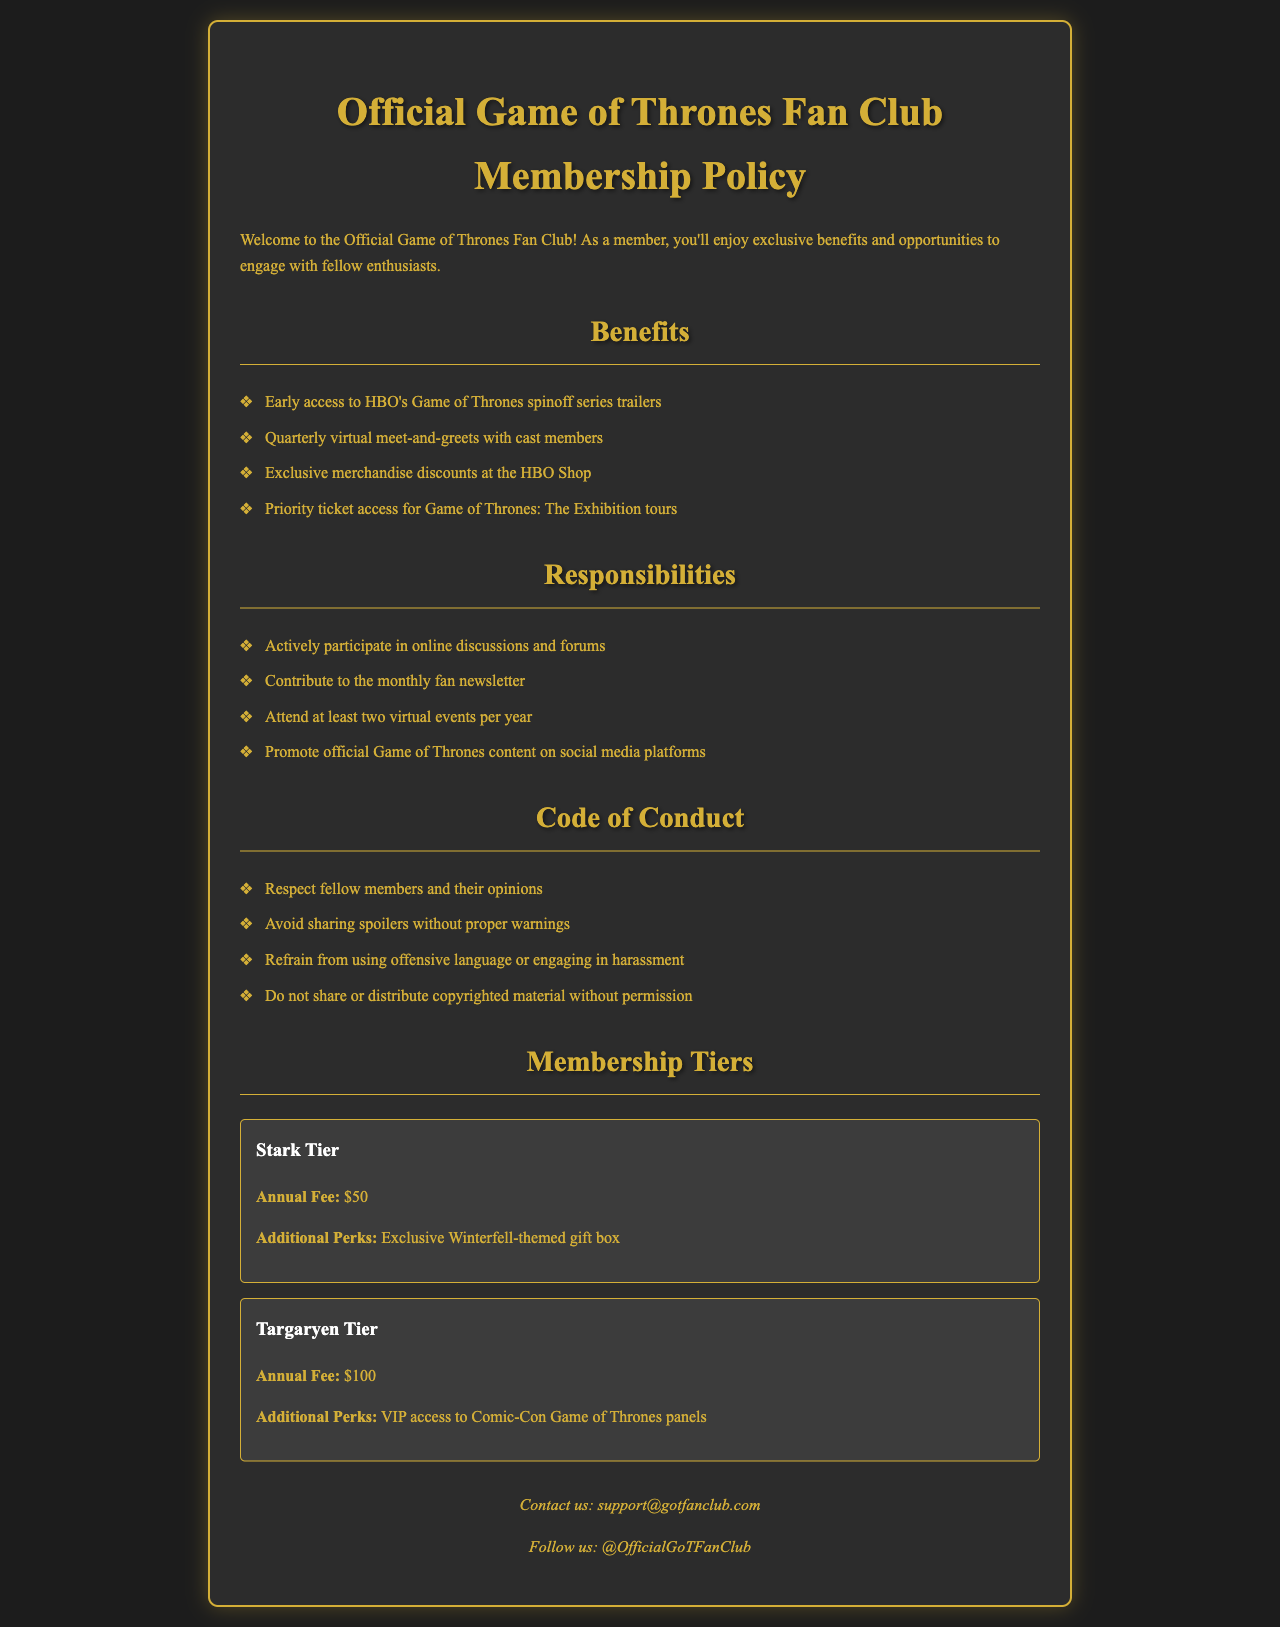What are the benefits of membership? The benefits of membership include early access to trailers, meet-and-greets with cast members, merchandise discounts, and priority ticket access.
Answer: Early access to HBO's Game of Thrones spinoff series trailers, quarterly virtual meet-and-greets with cast members, exclusive merchandise discounts at the HBO Shop, priority ticket access for Game of Thrones: The Exhibition tours How much is the annual fee for the Stark Tier? The annual fee for the Stark Tier is clearly stated in the document.
Answer: $50 What do members need to contribute to regularly? The document specifies a particular responsibility that members have regarding a specific publication.
Answer: The monthly fan newsletter What is a major responsibility of members? This responsibility highlights the importance of community engagement among members.
Answer: Actively participate in online discussions and forums What should members avoid sharing without warnings? This refers to a guideline in the document aimed at maintaining respectful communication.
Answer: Spoilers What exclusive perk is offered in the Targaryen Tier? This perk provides an opportunity to engage with content related to a major convention.
Answer: VIP access to Comic-Con Game of Thrones panels What platforms should members promote content on? The document highlights specific platforms to promote official content.
Answer: Social media platforms Which tier offers a Winterfell-themed gift box? This tier is associated with a specific theme and perks for members.
Answer: Stark Tier 